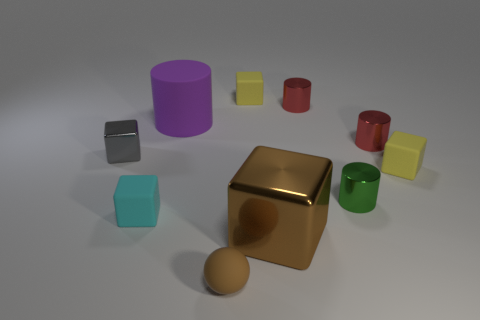Are there any green shiny cylinders that have the same size as the purple rubber object?
Your response must be concise. No. What is the material of the cylinder that is the same size as the brown metallic block?
Ensure brevity in your answer.  Rubber. What shape is the small red shiny object behind the purple cylinder?
Your answer should be very brief. Cylinder. Do the brown object that is right of the tiny matte sphere and the small yellow thing on the left side of the brown cube have the same material?
Provide a short and direct response. No. What number of other metallic things have the same shape as the gray shiny thing?
Make the answer very short. 1. There is a large block that is the same color as the matte ball; what is its material?
Provide a succinct answer. Metal. What number of objects are either cubes or tiny red shiny objects that are in front of the large purple matte cylinder?
Offer a very short reply. 6. What is the tiny brown thing made of?
Your answer should be compact. Rubber. There is a green thing that is the same shape as the purple matte thing; what material is it?
Your response must be concise. Metal. What is the color of the metal block that is on the left side of the brown matte sphere that is in front of the big brown block?
Ensure brevity in your answer.  Gray. 